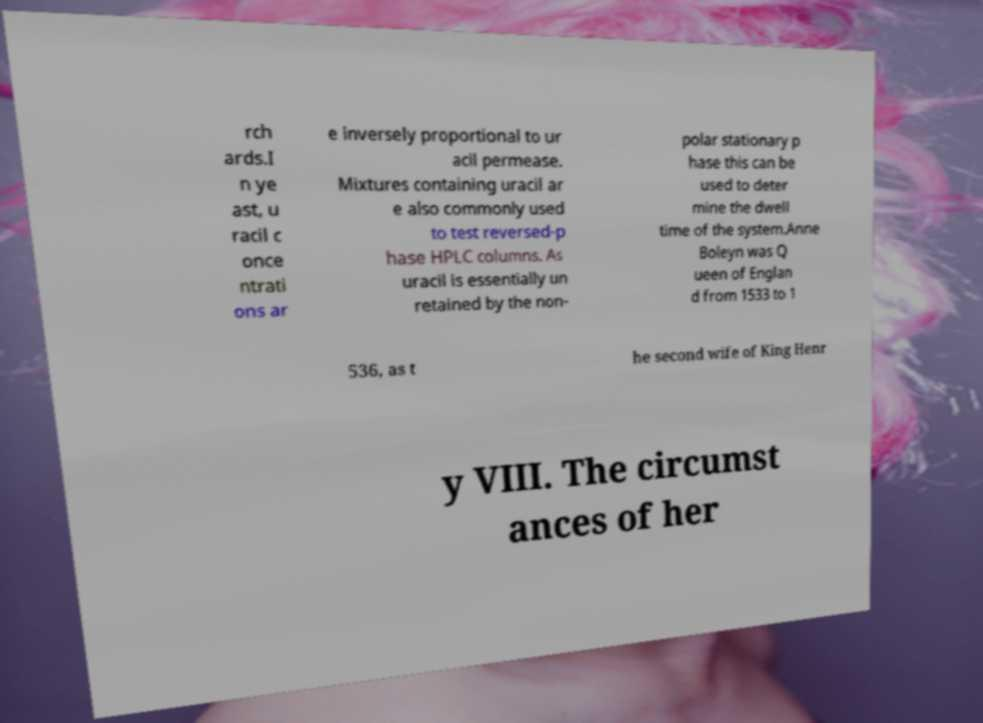Can you accurately transcribe the text from the provided image for me? rch ards.I n ye ast, u racil c once ntrati ons ar e inversely proportional to ur acil permease. Mixtures containing uracil ar e also commonly used to test reversed-p hase HPLC columns. As uracil is essentially un retained by the non- polar stationary p hase this can be used to deter mine the dwell time of the system.Anne Boleyn was Q ueen of Englan d from 1533 to 1 536, as t he second wife of King Henr y VIII. The circumst ances of her 